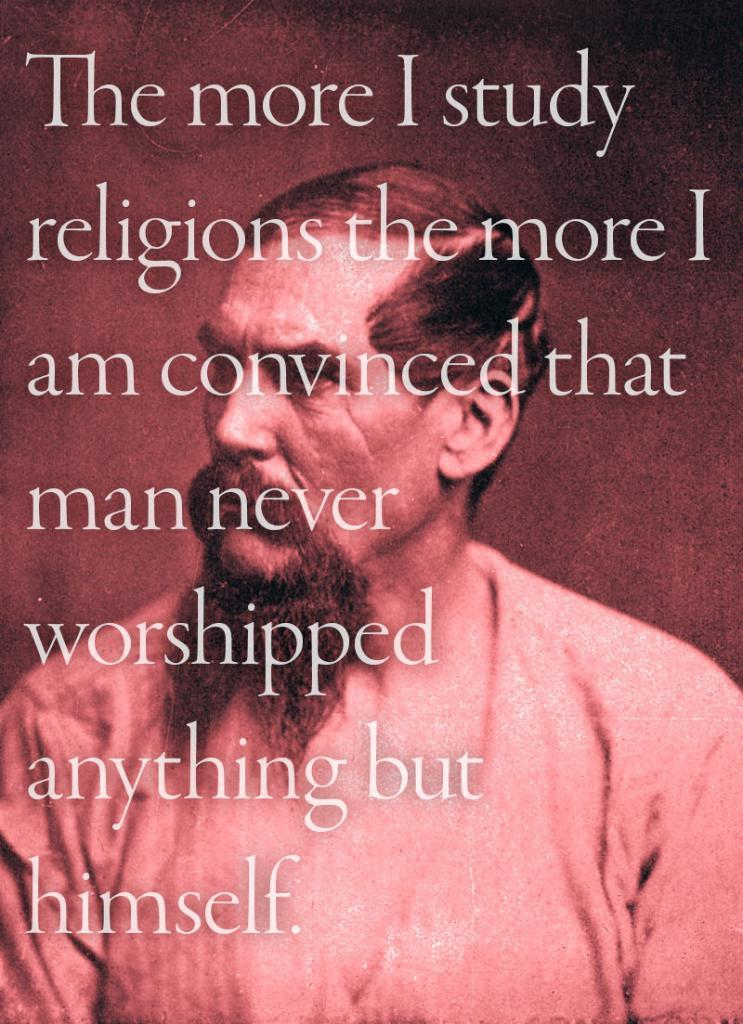What type of visual is the image? The image is a poster. Who or what is the main subject of the poster? There is a man depicted on the poster. Are there any words or phrases on the poster? Yes, there is text present on the poster. How many goats are visible on the poster? There are no goats present on the poster; it features a man and text. What type of pets are shown interacting with the man on the poster? There are no pets depicted on the poster; it only features a man and text. 